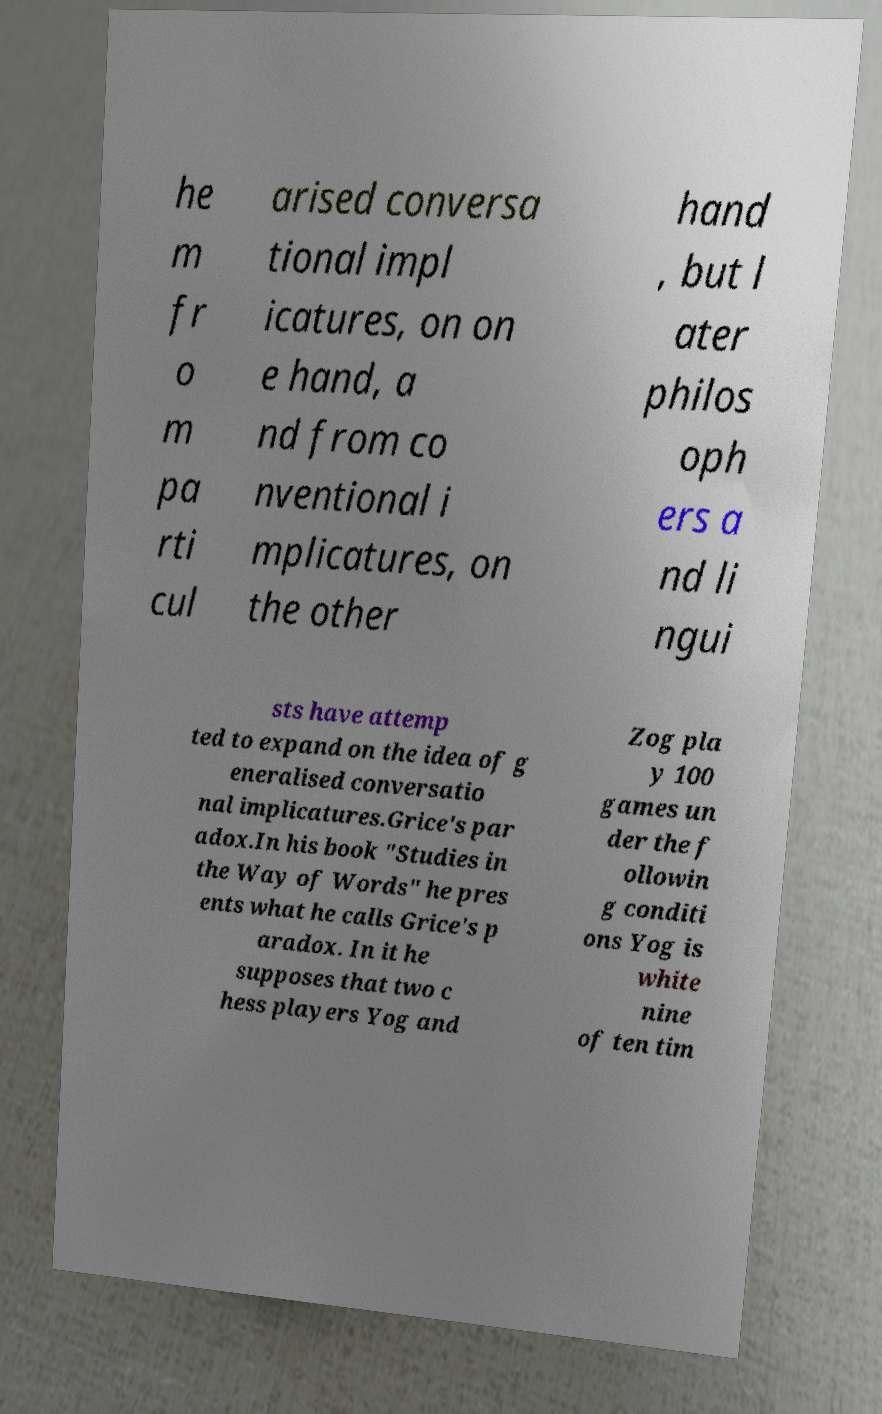Could you assist in decoding the text presented in this image and type it out clearly? he m fr o m pa rti cul arised conversa tional impl icatures, on on e hand, a nd from co nventional i mplicatures, on the other hand , but l ater philos oph ers a nd li ngui sts have attemp ted to expand on the idea of g eneralised conversatio nal implicatures.Grice's par adox.In his book "Studies in the Way of Words" he pres ents what he calls Grice's p aradox. In it he supposes that two c hess players Yog and Zog pla y 100 games un der the f ollowin g conditi ons Yog is white nine of ten tim 